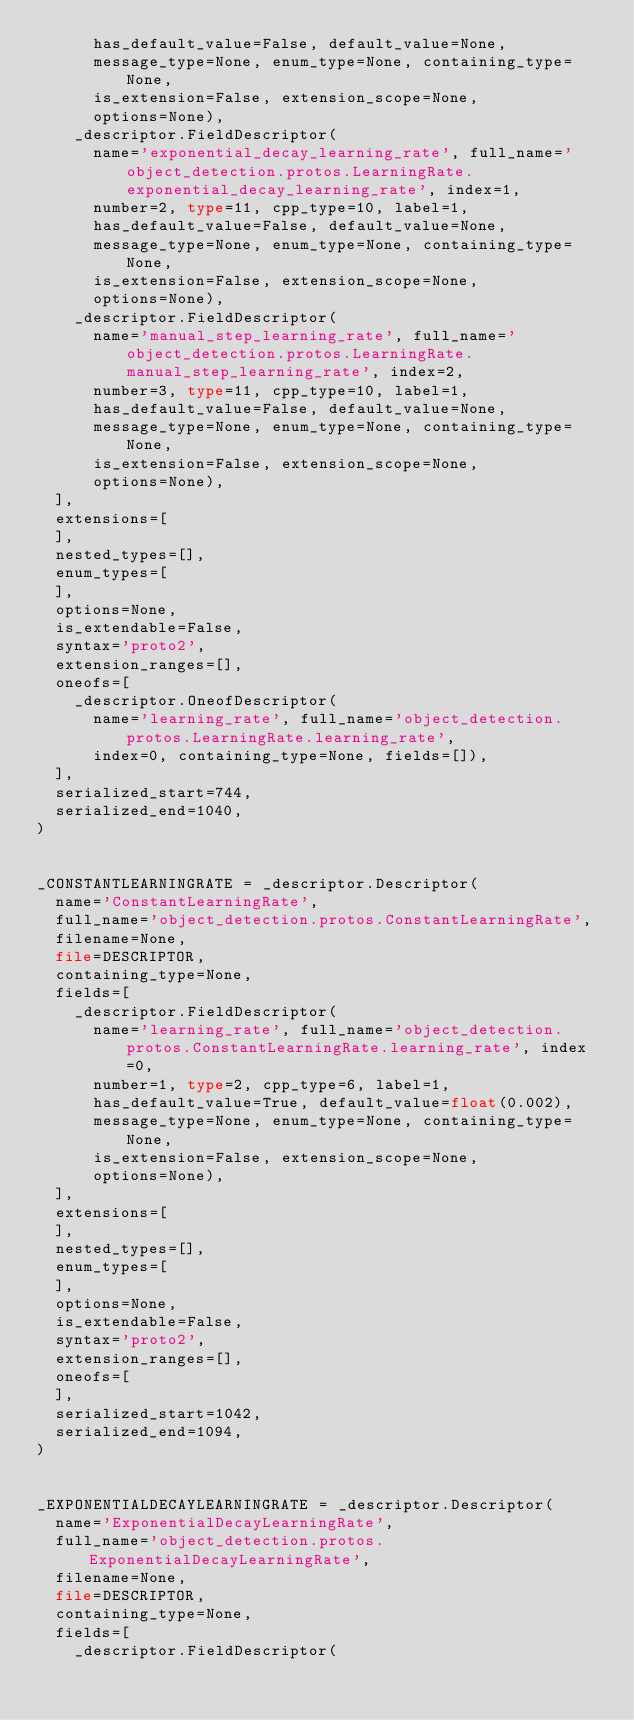<code> <loc_0><loc_0><loc_500><loc_500><_Python_>      has_default_value=False, default_value=None,
      message_type=None, enum_type=None, containing_type=None,
      is_extension=False, extension_scope=None,
      options=None),
    _descriptor.FieldDescriptor(
      name='exponential_decay_learning_rate', full_name='object_detection.protos.LearningRate.exponential_decay_learning_rate', index=1,
      number=2, type=11, cpp_type=10, label=1,
      has_default_value=False, default_value=None,
      message_type=None, enum_type=None, containing_type=None,
      is_extension=False, extension_scope=None,
      options=None),
    _descriptor.FieldDescriptor(
      name='manual_step_learning_rate', full_name='object_detection.protos.LearningRate.manual_step_learning_rate', index=2,
      number=3, type=11, cpp_type=10, label=1,
      has_default_value=False, default_value=None,
      message_type=None, enum_type=None, containing_type=None,
      is_extension=False, extension_scope=None,
      options=None),
  ],
  extensions=[
  ],
  nested_types=[],
  enum_types=[
  ],
  options=None,
  is_extendable=False,
  syntax='proto2',
  extension_ranges=[],
  oneofs=[
    _descriptor.OneofDescriptor(
      name='learning_rate', full_name='object_detection.protos.LearningRate.learning_rate',
      index=0, containing_type=None, fields=[]),
  ],
  serialized_start=744,
  serialized_end=1040,
)


_CONSTANTLEARNINGRATE = _descriptor.Descriptor(
  name='ConstantLearningRate',
  full_name='object_detection.protos.ConstantLearningRate',
  filename=None,
  file=DESCRIPTOR,
  containing_type=None,
  fields=[
    _descriptor.FieldDescriptor(
      name='learning_rate', full_name='object_detection.protos.ConstantLearningRate.learning_rate', index=0,
      number=1, type=2, cpp_type=6, label=1,
      has_default_value=True, default_value=float(0.002),
      message_type=None, enum_type=None, containing_type=None,
      is_extension=False, extension_scope=None,
      options=None),
  ],
  extensions=[
  ],
  nested_types=[],
  enum_types=[
  ],
  options=None,
  is_extendable=False,
  syntax='proto2',
  extension_ranges=[],
  oneofs=[
  ],
  serialized_start=1042,
  serialized_end=1094,
)


_EXPONENTIALDECAYLEARNINGRATE = _descriptor.Descriptor(
  name='ExponentialDecayLearningRate',
  full_name='object_detection.protos.ExponentialDecayLearningRate',
  filename=None,
  file=DESCRIPTOR,
  containing_type=None,
  fields=[
    _descriptor.FieldDescriptor(</code> 